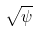Convert formula to latex. <formula><loc_0><loc_0><loc_500><loc_500>\sqrt { \psi }</formula> 